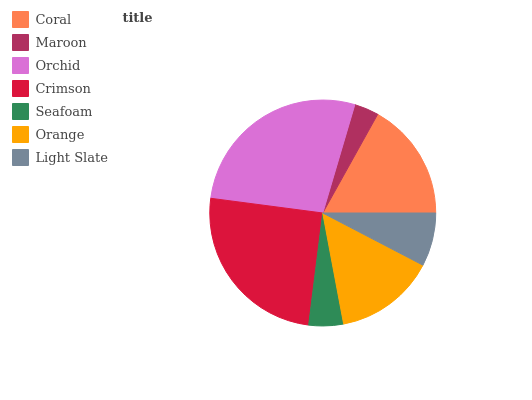Is Maroon the minimum?
Answer yes or no. Yes. Is Orchid the maximum?
Answer yes or no. Yes. Is Orchid the minimum?
Answer yes or no. No. Is Maroon the maximum?
Answer yes or no. No. Is Orchid greater than Maroon?
Answer yes or no. Yes. Is Maroon less than Orchid?
Answer yes or no. Yes. Is Maroon greater than Orchid?
Answer yes or no. No. Is Orchid less than Maroon?
Answer yes or no. No. Is Orange the high median?
Answer yes or no. Yes. Is Orange the low median?
Answer yes or no. Yes. Is Orchid the high median?
Answer yes or no. No. Is Maroon the low median?
Answer yes or no. No. 